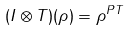<formula> <loc_0><loc_0><loc_500><loc_500>( I \otimes T ) ( \rho ) = \rho ^ { P T }</formula> 